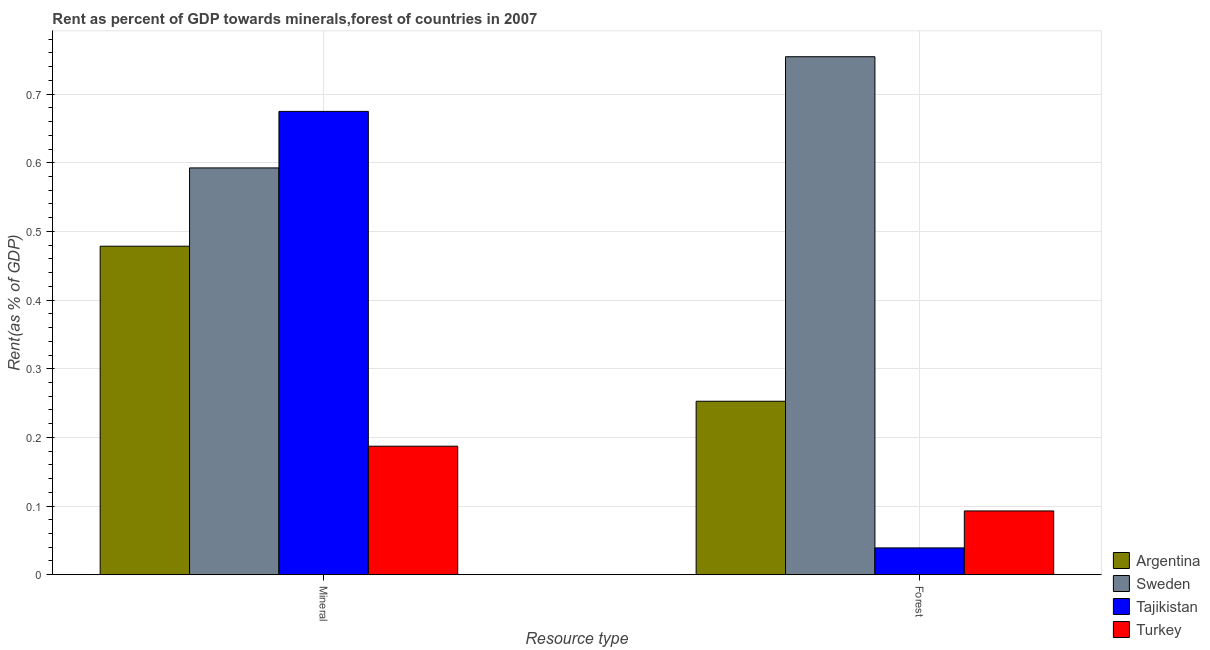How many different coloured bars are there?
Make the answer very short. 4. Are the number of bars per tick equal to the number of legend labels?
Give a very brief answer. Yes. Are the number of bars on each tick of the X-axis equal?
Offer a terse response. Yes. What is the label of the 2nd group of bars from the left?
Your response must be concise. Forest. What is the mineral rent in Turkey?
Your response must be concise. 0.19. Across all countries, what is the maximum forest rent?
Give a very brief answer. 0.75. Across all countries, what is the minimum mineral rent?
Your response must be concise. 0.19. In which country was the forest rent maximum?
Make the answer very short. Sweden. In which country was the mineral rent minimum?
Your answer should be compact. Turkey. What is the total forest rent in the graph?
Provide a succinct answer. 1.14. What is the difference between the mineral rent in Tajikistan and that in Turkey?
Ensure brevity in your answer.  0.49. What is the difference between the forest rent in Sweden and the mineral rent in Tajikistan?
Offer a terse response. 0.08. What is the average mineral rent per country?
Your answer should be compact. 0.48. What is the difference between the forest rent and mineral rent in Argentina?
Provide a short and direct response. -0.23. In how many countries, is the forest rent greater than 0.6400000000000001 %?
Make the answer very short. 1. What is the ratio of the forest rent in Argentina to that in Sweden?
Provide a succinct answer. 0.33. What does the 3rd bar from the left in Mineral represents?
Your answer should be compact. Tajikistan. What does the 2nd bar from the right in Forest represents?
Provide a short and direct response. Tajikistan. How many bars are there?
Give a very brief answer. 8. Are all the bars in the graph horizontal?
Your answer should be very brief. No. How many countries are there in the graph?
Ensure brevity in your answer.  4. What is the difference between two consecutive major ticks on the Y-axis?
Give a very brief answer. 0.1. Does the graph contain any zero values?
Keep it short and to the point. No. Where does the legend appear in the graph?
Offer a terse response. Bottom right. How many legend labels are there?
Offer a terse response. 4. How are the legend labels stacked?
Offer a very short reply. Vertical. What is the title of the graph?
Your answer should be very brief. Rent as percent of GDP towards minerals,forest of countries in 2007. What is the label or title of the X-axis?
Offer a terse response. Resource type. What is the label or title of the Y-axis?
Offer a terse response. Rent(as % of GDP). What is the Rent(as % of GDP) of Argentina in Mineral?
Offer a very short reply. 0.48. What is the Rent(as % of GDP) of Sweden in Mineral?
Keep it short and to the point. 0.59. What is the Rent(as % of GDP) in Tajikistan in Mineral?
Your answer should be very brief. 0.67. What is the Rent(as % of GDP) in Turkey in Mineral?
Provide a succinct answer. 0.19. What is the Rent(as % of GDP) in Argentina in Forest?
Offer a very short reply. 0.25. What is the Rent(as % of GDP) in Sweden in Forest?
Offer a very short reply. 0.75. What is the Rent(as % of GDP) of Tajikistan in Forest?
Your answer should be compact. 0.04. What is the Rent(as % of GDP) in Turkey in Forest?
Ensure brevity in your answer.  0.09. Across all Resource type, what is the maximum Rent(as % of GDP) in Argentina?
Your response must be concise. 0.48. Across all Resource type, what is the maximum Rent(as % of GDP) in Sweden?
Offer a terse response. 0.75. Across all Resource type, what is the maximum Rent(as % of GDP) of Tajikistan?
Offer a very short reply. 0.67. Across all Resource type, what is the maximum Rent(as % of GDP) in Turkey?
Ensure brevity in your answer.  0.19. Across all Resource type, what is the minimum Rent(as % of GDP) in Argentina?
Provide a succinct answer. 0.25. Across all Resource type, what is the minimum Rent(as % of GDP) of Sweden?
Your response must be concise. 0.59. Across all Resource type, what is the minimum Rent(as % of GDP) in Tajikistan?
Offer a very short reply. 0.04. Across all Resource type, what is the minimum Rent(as % of GDP) in Turkey?
Keep it short and to the point. 0.09. What is the total Rent(as % of GDP) of Argentina in the graph?
Offer a terse response. 0.73. What is the total Rent(as % of GDP) in Sweden in the graph?
Your answer should be compact. 1.35. What is the total Rent(as % of GDP) of Tajikistan in the graph?
Your answer should be compact. 0.71. What is the total Rent(as % of GDP) in Turkey in the graph?
Ensure brevity in your answer.  0.28. What is the difference between the Rent(as % of GDP) in Argentina in Mineral and that in Forest?
Keep it short and to the point. 0.23. What is the difference between the Rent(as % of GDP) in Sweden in Mineral and that in Forest?
Ensure brevity in your answer.  -0.16. What is the difference between the Rent(as % of GDP) in Tajikistan in Mineral and that in Forest?
Your response must be concise. 0.64. What is the difference between the Rent(as % of GDP) of Turkey in Mineral and that in Forest?
Provide a short and direct response. 0.09. What is the difference between the Rent(as % of GDP) in Argentina in Mineral and the Rent(as % of GDP) in Sweden in Forest?
Make the answer very short. -0.28. What is the difference between the Rent(as % of GDP) in Argentina in Mineral and the Rent(as % of GDP) in Tajikistan in Forest?
Your response must be concise. 0.44. What is the difference between the Rent(as % of GDP) in Argentina in Mineral and the Rent(as % of GDP) in Turkey in Forest?
Keep it short and to the point. 0.39. What is the difference between the Rent(as % of GDP) in Sweden in Mineral and the Rent(as % of GDP) in Tajikistan in Forest?
Offer a terse response. 0.55. What is the difference between the Rent(as % of GDP) in Sweden in Mineral and the Rent(as % of GDP) in Turkey in Forest?
Offer a very short reply. 0.5. What is the difference between the Rent(as % of GDP) of Tajikistan in Mineral and the Rent(as % of GDP) of Turkey in Forest?
Ensure brevity in your answer.  0.58. What is the average Rent(as % of GDP) of Argentina per Resource type?
Keep it short and to the point. 0.37. What is the average Rent(as % of GDP) in Sweden per Resource type?
Make the answer very short. 0.67. What is the average Rent(as % of GDP) in Tajikistan per Resource type?
Ensure brevity in your answer.  0.36. What is the average Rent(as % of GDP) in Turkey per Resource type?
Give a very brief answer. 0.14. What is the difference between the Rent(as % of GDP) in Argentina and Rent(as % of GDP) in Sweden in Mineral?
Offer a terse response. -0.11. What is the difference between the Rent(as % of GDP) in Argentina and Rent(as % of GDP) in Tajikistan in Mineral?
Give a very brief answer. -0.2. What is the difference between the Rent(as % of GDP) in Argentina and Rent(as % of GDP) in Turkey in Mineral?
Offer a very short reply. 0.29. What is the difference between the Rent(as % of GDP) of Sweden and Rent(as % of GDP) of Tajikistan in Mineral?
Ensure brevity in your answer.  -0.08. What is the difference between the Rent(as % of GDP) in Sweden and Rent(as % of GDP) in Turkey in Mineral?
Provide a short and direct response. 0.41. What is the difference between the Rent(as % of GDP) in Tajikistan and Rent(as % of GDP) in Turkey in Mineral?
Provide a short and direct response. 0.49. What is the difference between the Rent(as % of GDP) in Argentina and Rent(as % of GDP) in Sweden in Forest?
Keep it short and to the point. -0.5. What is the difference between the Rent(as % of GDP) in Argentina and Rent(as % of GDP) in Tajikistan in Forest?
Your answer should be compact. 0.21. What is the difference between the Rent(as % of GDP) in Argentina and Rent(as % of GDP) in Turkey in Forest?
Keep it short and to the point. 0.16. What is the difference between the Rent(as % of GDP) in Sweden and Rent(as % of GDP) in Tajikistan in Forest?
Offer a very short reply. 0.72. What is the difference between the Rent(as % of GDP) of Sweden and Rent(as % of GDP) of Turkey in Forest?
Make the answer very short. 0.66. What is the difference between the Rent(as % of GDP) in Tajikistan and Rent(as % of GDP) in Turkey in Forest?
Provide a short and direct response. -0.05. What is the ratio of the Rent(as % of GDP) of Argentina in Mineral to that in Forest?
Give a very brief answer. 1.89. What is the ratio of the Rent(as % of GDP) of Sweden in Mineral to that in Forest?
Your response must be concise. 0.79. What is the ratio of the Rent(as % of GDP) in Tajikistan in Mineral to that in Forest?
Your answer should be compact. 17.3. What is the ratio of the Rent(as % of GDP) of Turkey in Mineral to that in Forest?
Offer a terse response. 2.02. What is the difference between the highest and the second highest Rent(as % of GDP) in Argentina?
Keep it short and to the point. 0.23. What is the difference between the highest and the second highest Rent(as % of GDP) of Sweden?
Offer a terse response. 0.16. What is the difference between the highest and the second highest Rent(as % of GDP) of Tajikistan?
Provide a short and direct response. 0.64. What is the difference between the highest and the second highest Rent(as % of GDP) of Turkey?
Offer a very short reply. 0.09. What is the difference between the highest and the lowest Rent(as % of GDP) of Argentina?
Your answer should be very brief. 0.23. What is the difference between the highest and the lowest Rent(as % of GDP) of Sweden?
Your answer should be compact. 0.16. What is the difference between the highest and the lowest Rent(as % of GDP) in Tajikistan?
Provide a succinct answer. 0.64. What is the difference between the highest and the lowest Rent(as % of GDP) of Turkey?
Offer a very short reply. 0.09. 